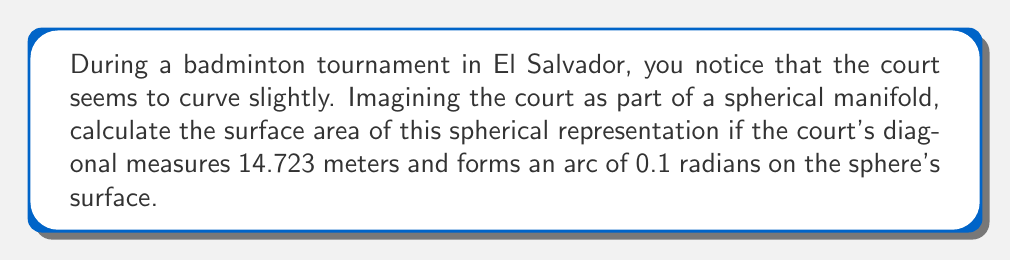Help me with this question. To solve this problem, we'll follow these steps:

1) First, recall that the surface area of a sphere is given by the formula:
   
   $$ A = 4\pi r^2 $$

   where $r$ is the radius of the sphere.

2) We need to find the radius of the sphere. We can do this using the arc length formula:
   
   $$ s = r\theta $$

   where $s$ is the arc length (court diagonal), $r$ is the radius, and $\theta$ is the angle in radians.

3) We're given that $s = 14.723$ meters and $\theta = 0.1$ radians. Let's substitute these into the arc length formula:

   $$ 14.723 = r(0.1) $$

4) Solving for $r$:
   
   $$ r = \frac{14.723}{0.1} = 147.23 \text{ meters} $$

5) Now that we have the radius, we can calculate the surface area using the formula from step 1:

   $$ A = 4\pi (147.23)^2 $$

6) Let's compute this:
   
   $$ A = 4\pi (21676.6729) $$
   $$ A = 271891.9458... \text{ square meters} $$

7) Rounding to two decimal places:
   
   $$ A \approx 271891.95 \text{ square meters} $$

This represents the total surface area of the spherical manifold that includes the badminton court.
Answer: The surface area of the spherical manifold is approximately 271891.95 square meters. 